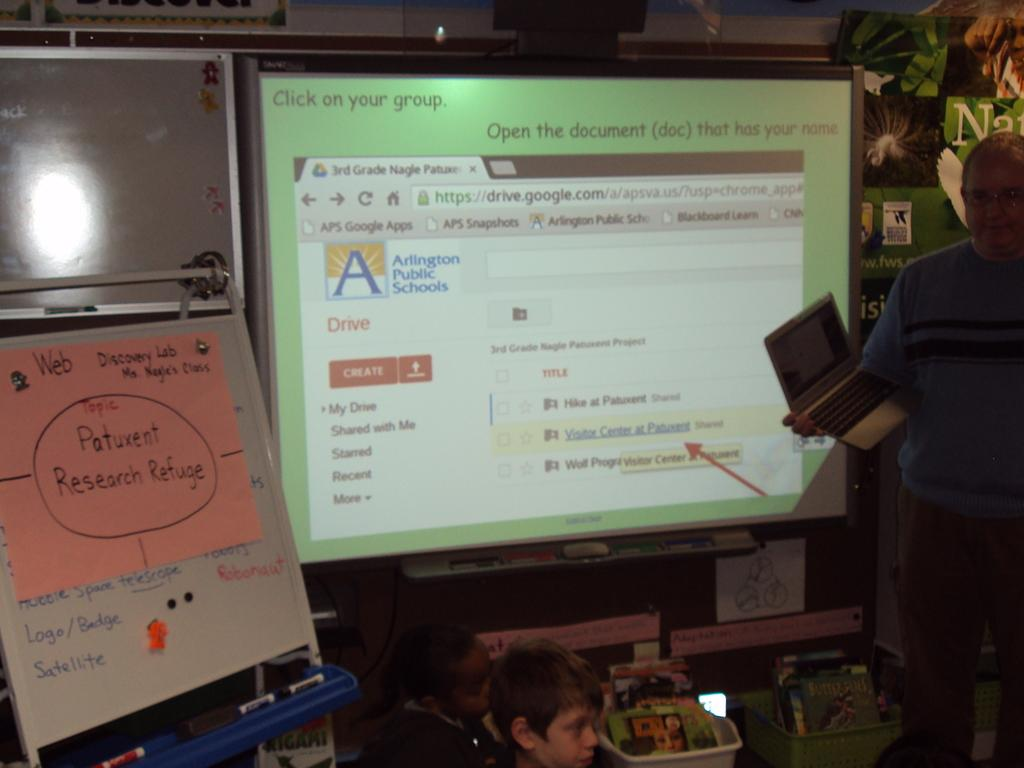<image>
Summarize the visual content of the image. The discussion here is about Patuxent research refuge. 